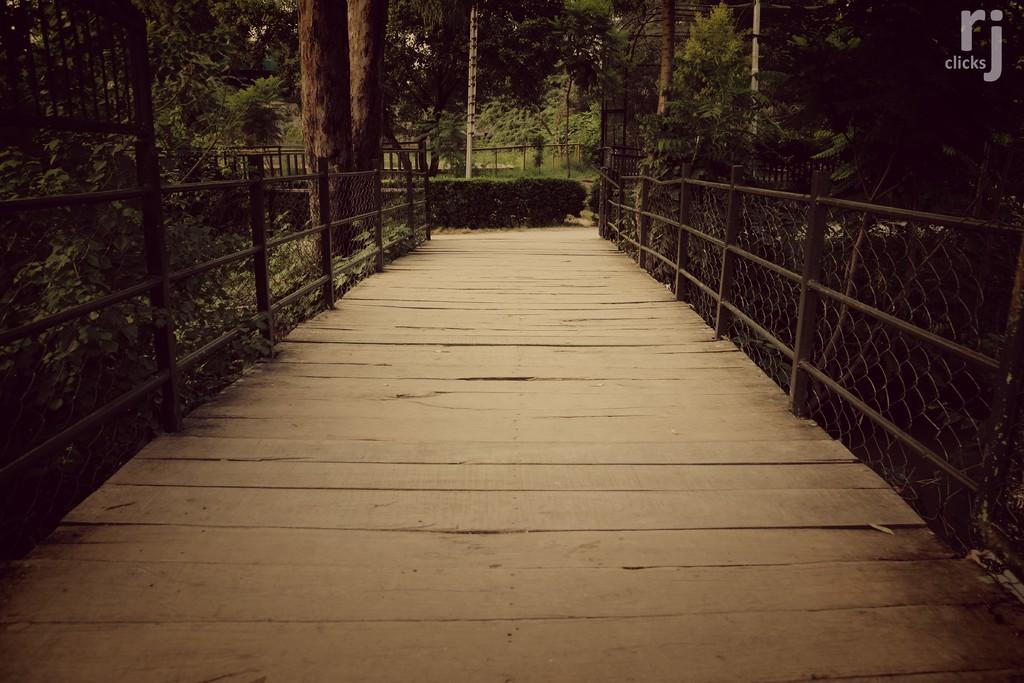What type of structure can be seen in the image? There is a bridge in the image. What other object is present in the image? There is a fence in the image. What type of vegetation is visible in the image? There are plants and trees in the image. How would you describe the lighting in the image? The image is slightly dark. Can you see any rabbits attending the party in the image? There is no party or rabbit present in the image. What type of zipper can be seen on the trees in the image? There are no zippers on the trees in the image; it features a bridge, fence, plants, and trees. 